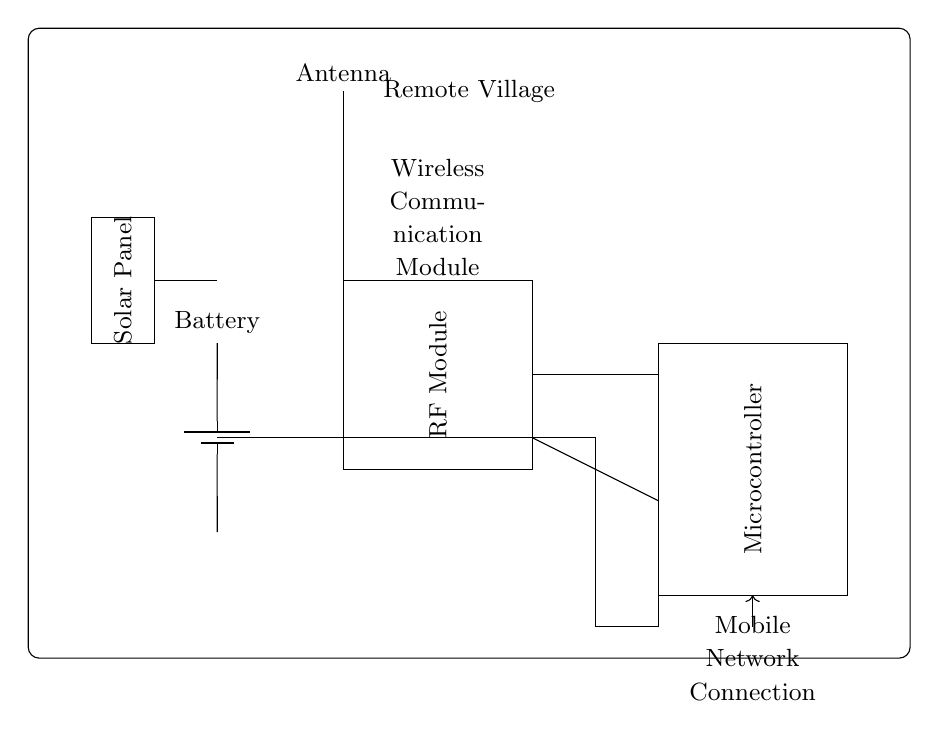What is the primary function of the antenna? The antenna is used for receiving and transmitting radio frequency signals, which connect the remote village to mobile networks.
Answer: Receiving and transmitting signals What component supplies power to the circuit? The battery is identified in the diagram as the component providing power, indicated by a battery symbol connected to the RF module, microcontroller, and solar panel.
Answer: Battery How many main components are there in the circuit? By counting the unique components shown in the circuit diagram (antenna, RF module, microcontroller, battery, and solar panel), we find there are five main components.
Answer: Five What is the role of the solar panel in this circuit? The solar panel provides an additional power source, which can be utilized to charge the battery and sustain the circuit, ensuring functionality even in remote areas.
Answer: Power source Which component connects to the mobile network? The connection to the mobile network is indicated as going out from the microcontroller, which is responsible for interfacing with the mobile network through the RF module.
Answer: Microcontroller 